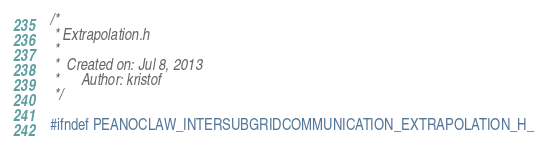Convert code to text. <code><loc_0><loc_0><loc_500><loc_500><_C_>/*
 * Extrapolation.h
 *
 *  Created on: Jul 8, 2013
 *      Author: kristof
 */

#ifndef PEANOCLAW_INTERSUBGRIDCOMMUNICATION_EXTRAPOLATION_H_</code> 